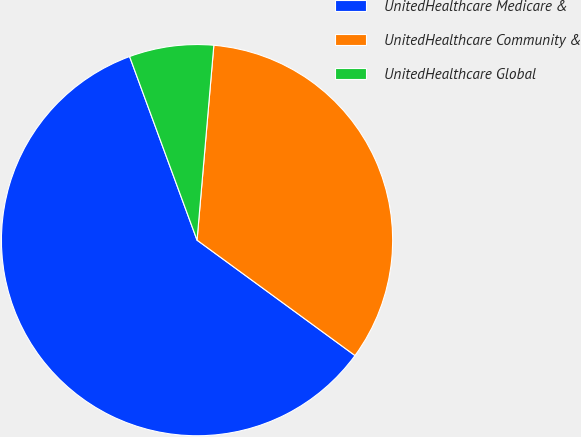Convert chart to OTSL. <chart><loc_0><loc_0><loc_500><loc_500><pie_chart><fcel>UnitedHealthcare Medicare &<fcel>UnitedHealthcare Community &<fcel>UnitedHealthcare Global<nl><fcel>59.35%<fcel>33.67%<fcel>6.97%<nl></chart> 